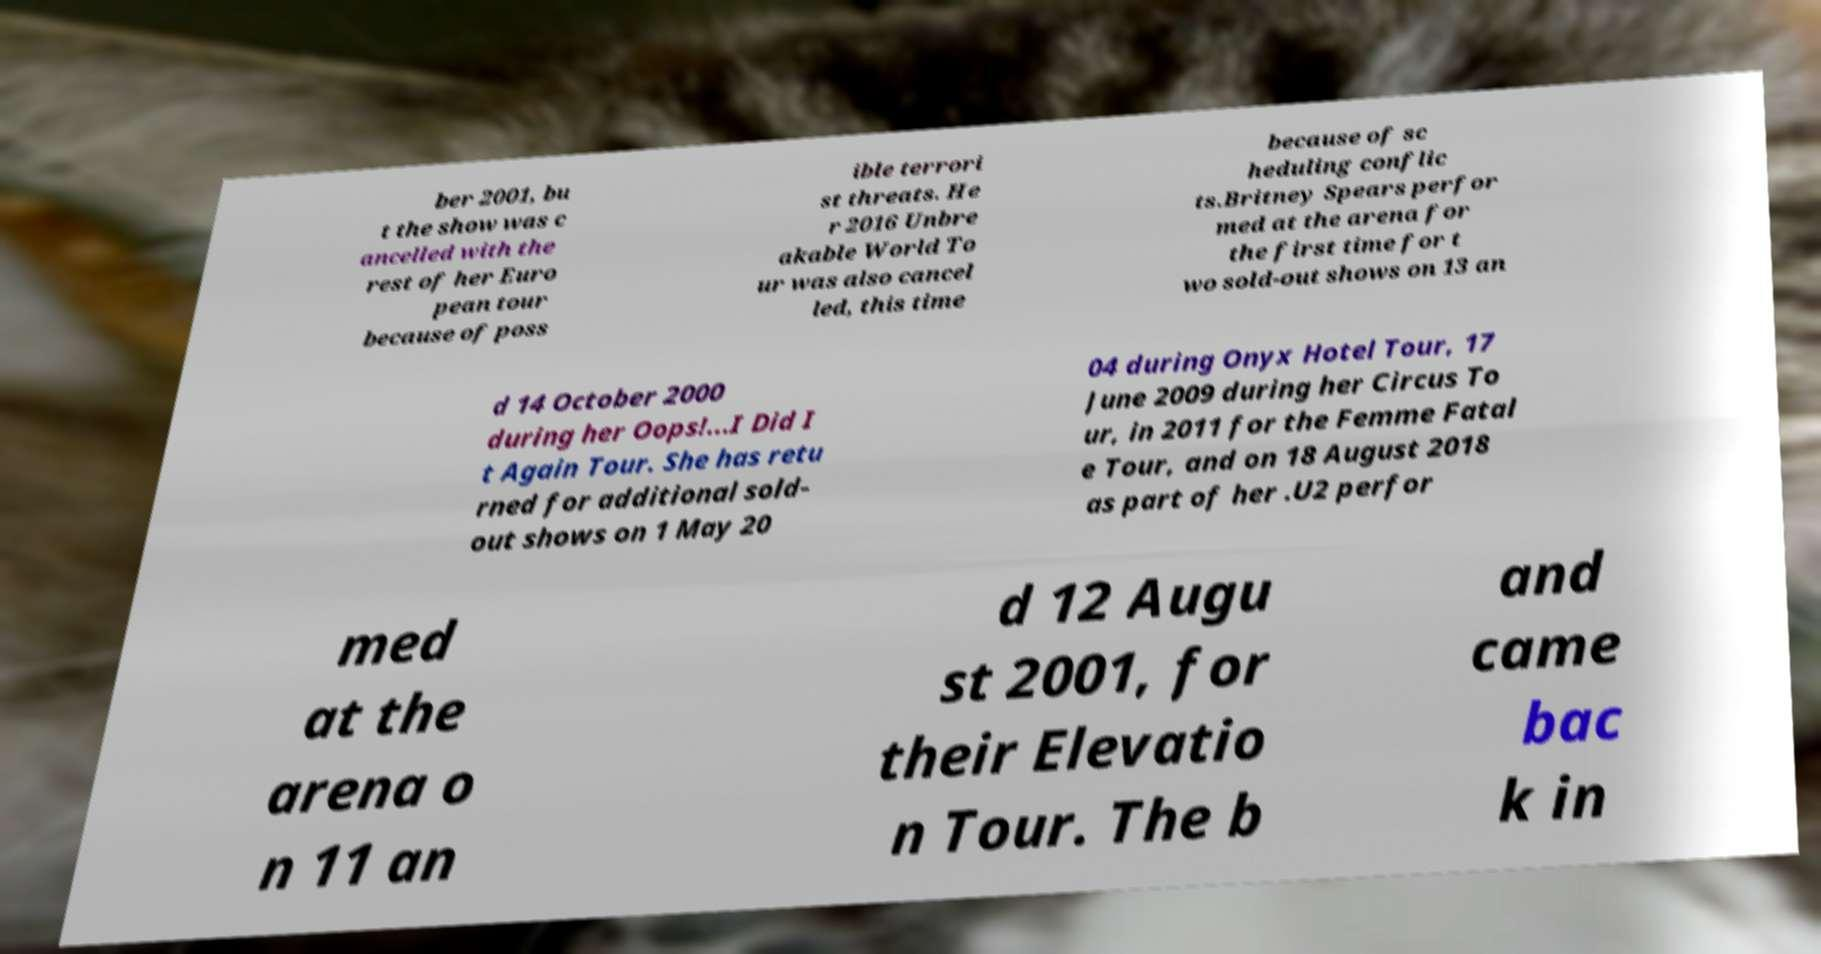Could you assist in decoding the text presented in this image and type it out clearly? ber 2001, bu t the show was c ancelled with the rest of her Euro pean tour because of poss ible terrori st threats. He r 2016 Unbre akable World To ur was also cancel led, this time because of sc heduling conflic ts.Britney Spears perfor med at the arena for the first time for t wo sold-out shows on 13 an d 14 October 2000 during her Oops!...I Did I t Again Tour. She has retu rned for additional sold- out shows on 1 May 20 04 during Onyx Hotel Tour, 17 June 2009 during her Circus To ur, in 2011 for the Femme Fatal e Tour, and on 18 August 2018 as part of her .U2 perfor med at the arena o n 11 an d 12 Augu st 2001, for their Elevatio n Tour. The b and came bac k in 